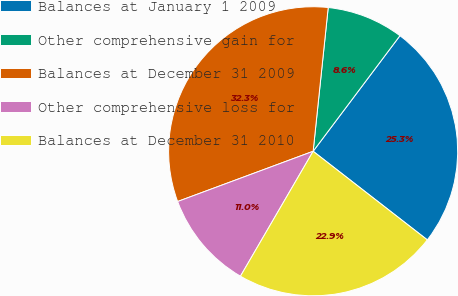Convert chart. <chart><loc_0><loc_0><loc_500><loc_500><pie_chart><fcel>Balances at January 1 2009<fcel>Other comprehensive gain for<fcel>Balances at December 31 2009<fcel>Other comprehensive loss for<fcel>Balances at December 31 2010<nl><fcel>25.25%<fcel>8.59%<fcel>32.31%<fcel>10.96%<fcel>22.88%<nl></chart> 